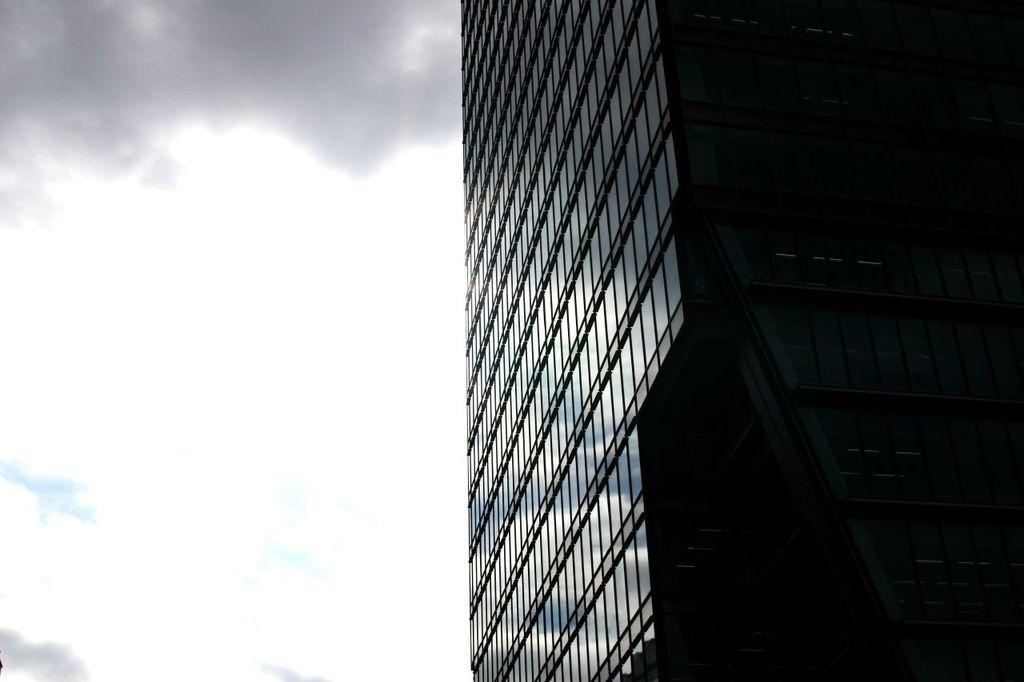What is the weather like on the left side of the image? The sky is cloudy on the left side of the image. What type of structure can be seen on the right side of the image? There is a building on the right side of the image. What type of feeling does the wren have in the image? There is no wren present in the image, so it is not possible to determine the feeling of a wren. 